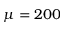<formula> <loc_0><loc_0><loc_500><loc_500>\mu = 2 0 0</formula> 